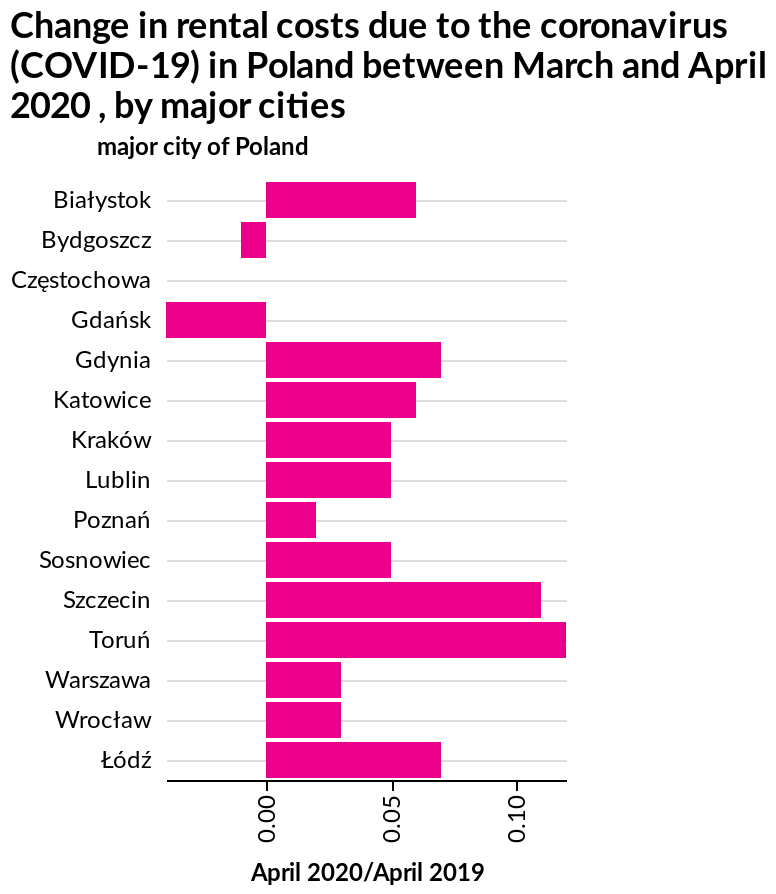<image>
Which cities had a decrease in rental costs?  Only two cities had a decrease in rental costs, Bydgoszcz and Gdansk. Which city had the biggest decrease in rental costs overall?  Gdansk had the biggest decrease in rental costs overall. What is the label for the x-axis on the bar diagram? The x-axis is labeled April 2020/April 2019. please summary the statistics and relations of the chart The biggest increase in cost for rental was in Torun, followed by Szczecin. Rental only decreased in 2 cities, Bydgoszcz and Gdansk, with Gdansk having the biggest decrease overall. Which cities experienced the biggest increase in rental costs?  The cities that experienced the biggest increase in rental costs were Torun and Szczecin. What is the name of the bar diagram?  The bar diagram is named Change in rental costs due to the coronavirus (COVID-19) in Poland between March and April 2020, by major cities. 